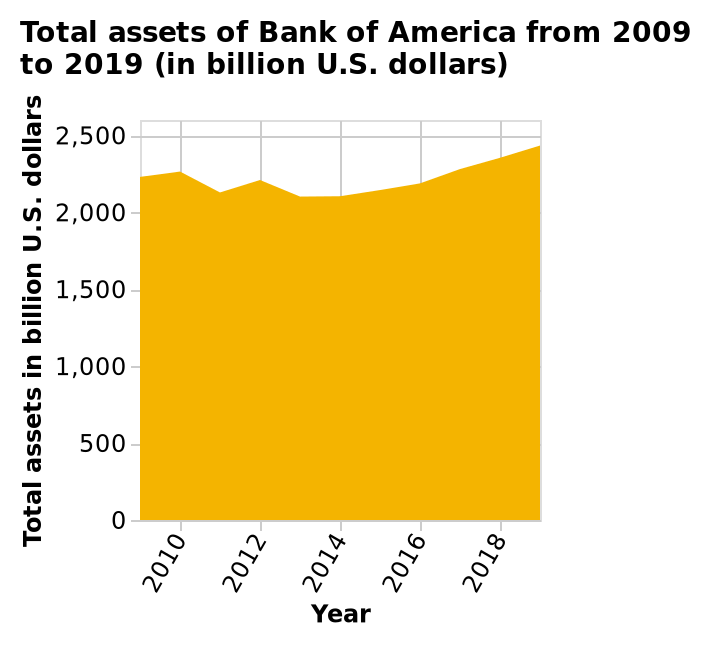<image>
please enumerates aspects of the construction of the chart Total assets of Bank of America from 2009 to 2019 (in billion U.S. dollars) is a area plot. Year is defined along the x-axis. The y-axis plots Total assets in billion U.S. dollars. What is the unit of measurement for the y-axis of the area plot? The unit of measurement for the y-axis of the area plot is billion U.S. dollars. please summary the statistics and relations of the chart Overall the total assets in billions has increased over the last 8 years apart from 2 little dips in 2011 and 2013. 